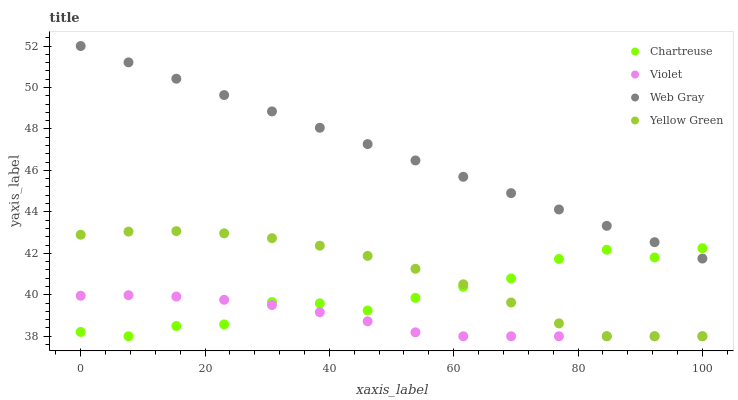Does Violet have the minimum area under the curve?
Answer yes or no. Yes. Does Web Gray have the maximum area under the curve?
Answer yes or no. Yes. Does Yellow Green have the minimum area under the curve?
Answer yes or no. No. Does Yellow Green have the maximum area under the curve?
Answer yes or no. No. Is Web Gray the smoothest?
Answer yes or no. Yes. Is Chartreuse the roughest?
Answer yes or no. Yes. Is Yellow Green the smoothest?
Answer yes or no. No. Is Yellow Green the roughest?
Answer yes or no. No. Does Chartreuse have the lowest value?
Answer yes or no. Yes. Does Web Gray have the lowest value?
Answer yes or no. No. Does Web Gray have the highest value?
Answer yes or no. Yes. Does Yellow Green have the highest value?
Answer yes or no. No. Is Violet less than Web Gray?
Answer yes or no. Yes. Is Web Gray greater than Yellow Green?
Answer yes or no. Yes. Does Chartreuse intersect Web Gray?
Answer yes or no. Yes. Is Chartreuse less than Web Gray?
Answer yes or no. No. Is Chartreuse greater than Web Gray?
Answer yes or no. No. Does Violet intersect Web Gray?
Answer yes or no. No. 